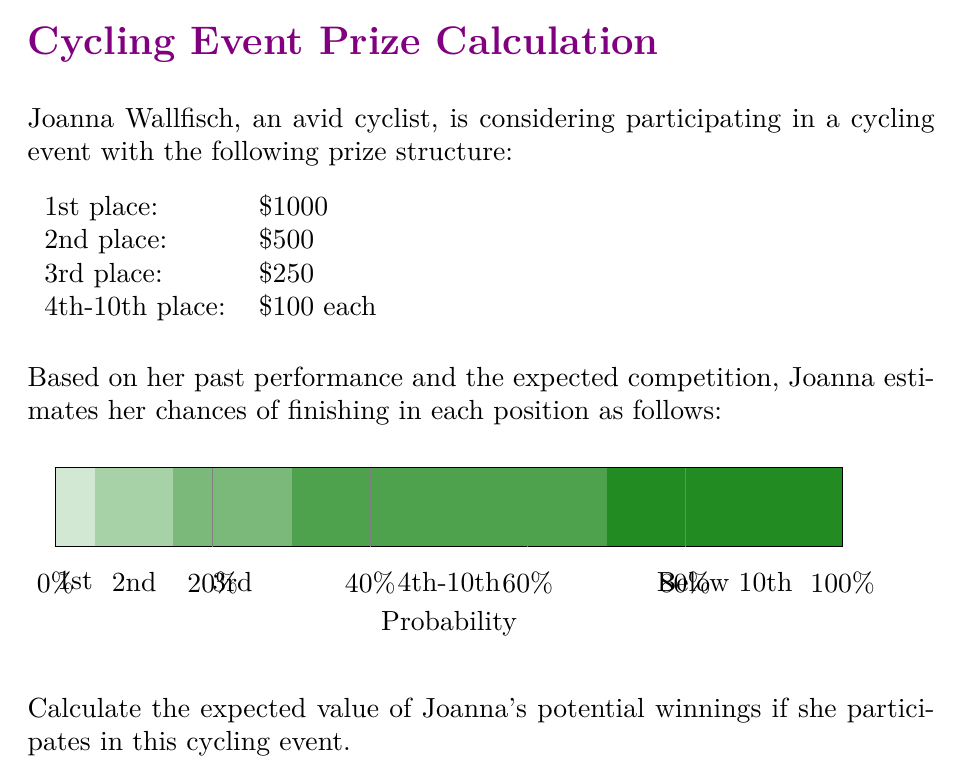Help me with this question. To calculate the expected value of Joanna's potential winnings, we need to multiply each possible prize amount by its probability of occurrence and then sum these products. Let's break it down step by step:

1) For 1st place:
   Probability = 0.05
   Prize = $1000
   Expected value = $1000 * 0.05 = $50

2) For 2nd place:
   Probability = 0.10
   Prize = $500
   Expected value = $500 * 0.10 = $50

3) For 3rd place:
   Probability = 0.15
   Prize = $250
   Expected value = $250 * 0.15 = $37.50

4) For 4th-10th place:
   Probability = 0.40
   Prize = $100
   Expected value = $100 * 0.40 = $40

5) For below 10th place:
   Probability = 0.30
   Prize = $0
   Expected value = $0 * 0.30 = $0

Now, we sum all these expected values:

$$ E(\text{winnings}) = 50 + 50 + 37.50 + 40 + 0 = $177.50 $$

Therefore, the expected value of Joanna's potential winnings is $177.50.

This can also be expressed mathematically as:

$$ E(\text{winnings}) = \sum_{i=1}^{n} p_i \cdot x_i $$

Where $p_i$ is the probability of each outcome and $x_i$ is the corresponding prize amount.
Answer: $177.50 